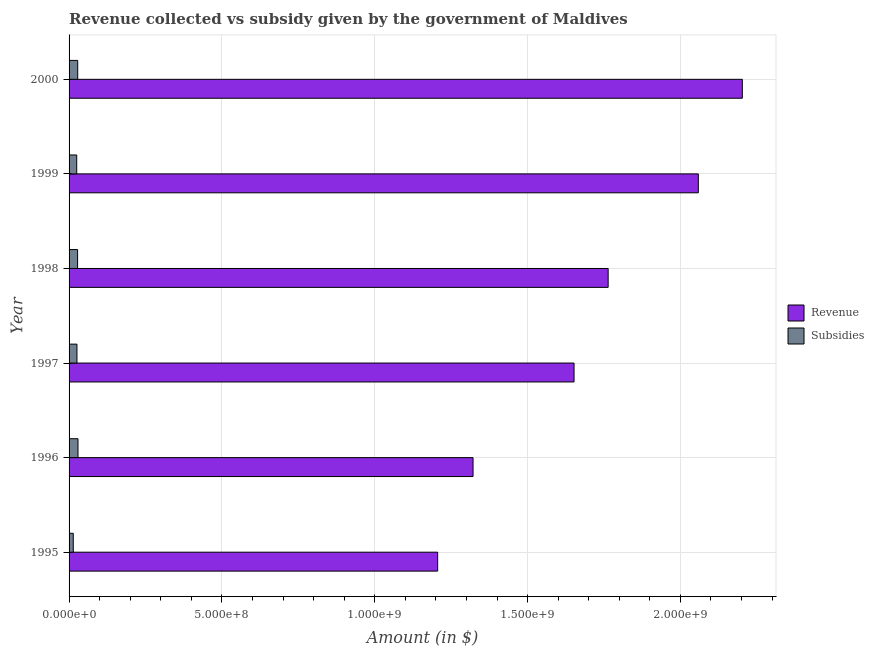How many different coloured bars are there?
Your response must be concise. 2. Are the number of bars per tick equal to the number of legend labels?
Your response must be concise. Yes. Are the number of bars on each tick of the Y-axis equal?
Keep it short and to the point. Yes. What is the label of the 1st group of bars from the top?
Your response must be concise. 2000. In how many cases, is the number of bars for a given year not equal to the number of legend labels?
Your answer should be very brief. 0. What is the amount of revenue collected in 2000?
Keep it short and to the point. 2.20e+09. Across all years, what is the maximum amount of revenue collected?
Give a very brief answer. 2.20e+09. Across all years, what is the minimum amount of subsidies given?
Offer a very short reply. 1.37e+07. What is the total amount of revenue collected in the graph?
Your response must be concise. 1.02e+1. What is the difference between the amount of revenue collected in 1996 and that in 1997?
Ensure brevity in your answer.  -3.30e+08. What is the difference between the amount of subsidies given in 1999 and the amount of revenue collected in 1996?
Offer a terse response. -1.30e+09. What is the average amount of revenue collected per year?
Your answer should be very brief. 1.70e+09. In the year 1996, what is the difference between the amount of revenue collected and amount of subsidies given?
Your response must be concise. 1.29e+09. In how many years, is the amount of revenue collected greater than 800000000 $?
Your response must be concise. 6. What is the ratio of the amount of revenue collected in 1996 to that in 1999?
Provide a succinct answer. 0.64. Is the amount of subsidies given in 1996 less than that in 2000?
Your answer should be compact. No. Is the difference between the amount of subsidies given in 1997 and 1998 greater than the difference between the amount of revenue collected in 1997 and 1998?
Ensure brevity in your answer.  Yes. What is the difference between the highest and the second highest amount of subsidies given?
Provide a succinct answer. 9.00e+05. What is the difference between the highest and the lowest amount of subsidies given?
Keep it short and to the point. 1.55e+07. What does the 1st bar from the top in 1998 represents?
Ensure brevity in your answer.  Subsidies. What does the 1st bar from the bottom in 2000 represents?
Offer a very short reply. Revenue. Where does the legend appear in the graph?
Ensure brevity in your answer.  Center right. What is the title of the graph?
Your answer should be compact. Revenue collected vs subsidy given by the government of Maldives. What is the label or title of the X-axis?
Your answer should be very brief. Amount (in $). What is the label or title of the Y-axis?
Give a very brief answer. Year. What is the Amount (in $) of Revenue in 1995?
Ensure brevity in your answer.  1.21e+09. What is the Amount (in $) of Subsidies in 1995?
Provide a succinct answer. 1.37e+07. What is the Amount (in $) in Revenue in 1996?
Your answer should be compact. 1.32e+09. What is the Amount (in $) in Subsidies in 1996?
Your answer should be compact. 2.92e+07. What is the Amount (in $) in Revenue in 1997?
Offer a terse response. 1.65e+09. What is the Amount (in $) in Subsidies in 1997?
Provide a succinct answer. 2.58e+07. What is the Amount (in $) of Revenue in 1998?
Give a very brief answer. 1.76e+09. What is the Amount (in $) of Subsidies in 1998?
Make the answer very short. 2.79e+07. What is the Amount (in $) in Revenue in 1999?
Provide a succinct answer. 2.06e+09. What is the Amount (in $) in Subsidies in 1999?
Provide a short and direct response. 2.50e+07. What is the Amount (in $) in Revenue in 2000?
Ensure brevity in your answer.  2.20e+09. What is the Amount (in $) of Subsidies in 2000?
Give a very brief answer. 2.83e+07. Across all years, what is the maximum Amount (in $) in Revenue?
Keep it short and to the point. 2.20e+09. Across all years, what is the maximum Amount (in $) of Subsidies?
Offer a terse response. 2.92e+07. Across all years, what is the minimum Amount (in $) in Revenue?
Your answer should be very brief. 1.21e+09. Across all years, what is the minimum Amount (in $) in Subsidies?
Provide a short and direct response. 1.37e+07. What is the total Amount (in $) in Revenue in the graph?
Ensure brevity in your answer.  1.02e+1. What is the total Amount (in $) of Subsidies in the graph?
Your answer should be compact. 1.50e+08. What is the difference between the Amount (in $) of Revenue in 1995 and that in 1996?
Give a very brief answer. -1.16e+08. What is the difference between the Amount (in $) in Subsidies in 1995 and that in 1996?
Ensure brevity in your answer.  -1.55e+07. What is the difference between the Amount (in $) in Revenue in 1995 and that in 1997?
Make the answer very short. -4.46e+08. What is the difference between the Amount (in $) of Subsidies in 1995 and that in 1997?
Make the answer very short. -1.21e+07. What is the difference between the Amount (in $) of Revenue in 1995 and that in 1998?
Keep it short and to the point. -5.58e+08. What is the difference between the Amount (in $) in Subsidies in 1995 and that in 1998?
Provide a short and direct response. -1.42e+07. What is the difference between the Amount (in $) in Revenue in 1995 and that in 1999?
Ensure brevity in your answer.  -8.53e+08. What is the difference between the Amount (in $) in Subsidies in 1995 and that in 1999?
Your response must be concise. -1.13e+07. What is the difference between the Amount (in $) in Revenue in 1995 and that in 2000?
Give a very brief answer. -9.97e+08. What is the difference between the Amount (in $) of Subsidies in 1995 and that in 2000?
Provide a short and direct response. -1.46e+07. What is the difference between the Amount (in $) in Revenue in 1996 and that in 1997?
Provide a succinct answer. -3.30e+08. What is the difference between the Amount (in $) of Subsidies in 1996 and that in 1997?
Ensure brevity in your answer.  3.40e+06. What is the difference between the Amount (in $) of Revenue in 1996 and that in 1998?
Ensure brevity in your answer.  -4.42e+08. What is the difference between the Amount (in $) of Subsidies in 1996 and that in 1998?
Make the answer very short. 1.30e+06. What is the difference between the Amount (in $) in Revenue in 1996 and that in 1999?
Provide a succinct answer. -7.37e+08. What is the difference between the Amount (in $) in Subsidies in 1996 and that in 1999?
Your answer should be very brief. 4.20e+06. What is the difference between the Amount (in $) in Revenue in 1996 and that in 2000?
Provide a short and direct response. -8.81e+08. What is the difference between the Amount (in $) in Revenue in 1997 and that in 1998?
Make the answer very short. -1.12e+08. What is the difference between the Amount (in $) of Subsidies in 1997 and that in 1998?
Your response must be concise. -2.10e+06. What is the difference between the Amount (in $) in Revenue in 1997 and that in 1999?
Provide a short and direct response. -4.07e+08. What is the difference between the Amount (in $) in Revenue in 1997 and that in 2000?
Your answer should be compact. -5.51e+08. What is the difference between the Amount (in $) in Subsidies in 1997 and that in 2000?
Provide a succinct answer. -2.50e+06. What is the difference between the Amount (in $) of Revenue in 1998 and that in 1999?
Give a very brief answer. -2.95e+08. What is the difference between the Amount (in $) of Subsidies in 1998 and that in 1999?
Your answer should be compact. 2.90e+06. What is the difference between the Amount (in $) in Revenue in 1998 and that in 2000?
Make the answer very short. -4.39e+08. What is the difference between the Amount (in $) in Subsidies in 1998 and that in 2000?
Your answer should be very brief. -4.00e+05. What is the difference between the Amount (in $) in Revenue in 1999 and that in 2000?
Make the answer very short. -1.44e+08. What is the difference between the Amount (in $) of Subsidies in 1999 and that in 2000?
Provide a succinct answer. -3.30e+06. What is the difference between the Amount (in $) of Revenue in 1995 and the Amount (in $) of Subsidies in 1996?
Keep it short and to the point. 1.18e+09. What is the difference between the Amount (in $) of Revenue in 1995 and the Amount (in $) of Subsidies in 1997?
Give a very brief answer. 1.18e+09. What is the difference between the Amount (in $) of Revenue in 1995 and the Amount (in $) of Subsidies in 1998?
Your response must be concise. 1.18e+09. What is the difference between the Amount (in $) of Revenue in 1995 and the Amount (in $) of Subsidies in 1999?
Offer a terse response. 1.18e+09. What is the difference between the Amount (in $) in Revenue in 1995 and the Amount (in $) in Subsidies in 2000?
Give a very brief answer. 1.18e+09. What is the difference between the Amount (in $) of Revenue in 1996 and the Amount (in $) of Subsidies in 1997?
Provide a succinct answer. 1.30e+09. What is the difference between the Amount (in $) of Revenue in 1996 and the Amount (in $) of Subsidies in 1998?
Keep it short and to the point. 1.29e+09. What is the difference between the Amount (in $) of Revenue in 1996 and the Amount (in $) of Subsidies in 1999?
Make the answer very short. 1.30e+09. What is the difference between the Amount (in $) of Revenue in 1996 and the Amount (in $) of Subsidies in 2000?
Keep it short and to the point. 1.29e+09. What is the difference between the Amount (in $) in Revenue in 1997 and the Amount (in $) in Subsidies in 1998?
Offer a very short reply. 1.62e+09. What is the difference between the Amount (in $) in Revenue in 1997 and the Amount (in $) in Subsidies in 1999?
Your answer should be very brief. 1.63e+09. What is the difference between the Amount (in $) of Revenue in 1997 and the Amount (in $) of Subsidies in 2000?
Ensure brevity in your answer.  1.62e+09. What is the difference between the Amount (in $) of Revenue in 1998 and the Amount (in $) of Subsidies in 1999?
Make the answer very short. 1.74e+09. What is the difference between the Amount (in $) of Revenue in 1998 and the Amount (in $) of Subsidies in 2000?
Offer a very short reply. 1.74e+09. What is the difference between the Amount (in $) of Revenue in 1999 and the Amount (in $) of Subsidies in 2000?
Keep it short and to the point. 2.03e+09. What is the average Amount (in $) in Revenue per year?
Ensure brevity in your answer.  1.70e+09. What is the average Amount (in $) in Subsidies per year?
Give a very brief answer. 2.50e+07. In the year 1995, what is the difference between the Amount (in $) in Revenue and Amount (in $) in Subsidies?
Your answer should be compact. 1.19e+09. In the year 1996, what is the difference between the Amount (in $) in Revenue and Amount (in $) in Subsidies?
Provide a succinct answer. 1.29e+09. In the year 1997, what is the difference between the Amount (in $) of Revenue and Amount (in $) of Subsidies?
Keep it short and to the point. 1.63e+09. In the year 1998, what is the difference between the Amount (in $) of Revenue and Amount (in $) of Subsidies?
Provide a short and direct response. 1.74e+09. In the year 1999, what is the difference between the Amount (in $) in Revenue and Amount (in $) in Subsidies?
Provide a short and direct response. 2.03e+09. In the year 2000, what is the difference between the Amount (in $) in Revenue and Amount (in $) in Subsidies?
Keep it short and to the point. 2.17e+09. What is the ratio of the Amount (in $) of Revenue in 1995 to that in 1996?
Provide a short and direct response. 0.91. What is the ratio of the Amount (in $) of Subsidies in 1995 to that in 1996?
Provide a short and direct response. 0.47. What is the ratio of the Amount (in $) in Revenue in 1995 to that in 1997?
Keep it short and to the point. 0.73. What is the ratio of the Amount (in $) of Subsidies in 1995 to that in 1997?
Keep it short and to the point. 0.53. What is the ratio of the Amount (in $) of Revenue in 1995 to that in 1998?
Provide a short and direct response. 0.68. What is the ratio of the Amount (in $) in Subsidies in 1995 to that in 1998?
Your response must be concise. 0.49. What is the ratio of the Amount (in $) in Revenue in 1995 to that in 1999?
Make the answer very short. 0.59. What is the ratio of the Amount (in $) in Subsidies in 1995 to that in 1999?
Give a very brief answer. 0.55. What is the ratio of the Amount (in $) of Revenue in 1995 to that in 2000?
Give a very brief answer. 0.55. What is the ratio of the Amount (in $) in Subsidies in 1995 to that in 2000?
Make the answer very short. 0.48. What is the ratio of the Amount (in $) in Revenue in 1996 to that in 1997?
Your answer should be compact. 0.8. What is the ratio of the Amount (in $) in Subsidies in 1996 to that in 1997?
Make the answer very short. 1.13. What is the ratio of the Amount (in $) of Revenue in 1996 to that in 1998?
Your response must be concise. 0.75. What is the ratio of the Amount (in $) in Subsidies in 1996 to that in 1998?
Ensure brevity in your answer.  1.05. What is the ratio of the Amount (in $) of Revenue in 1996 to that in 1999?
Provide a short and direct response. 0.64. What is the ratio of the Amount (in $) in Subsidies in 1996 to that in 1999?
Give a very brief answer. 1.17. What is the ratio of the Amount (in $) in Revenue in 1996 to that in 2000?
Keep it short and to the point. 0.6. What is the ratio of the Amount (in $) in Subsidies in 1996 to that in 2000?
Offer a very short reply. 1.03. What is the ratio of the Amount (in $) of Revenue in 1997 to that in 1998?
Make the answer very short. 0.94. What is the ratio of the Amount (in $) of Subsidies in 1997 to that in 1998?
Give a very brief answer. 0.92. What is the ratio of the Amount (in $) of Revenue in 1997 to that in 1999?
Your answer should be very brief. 0.8. What is the ratio of the Amount (in $) in Subsidies in 1997 to that in 1999?
Make the answer very short. 1.03. What is the ratio of the Amount (in $) in Revenue in 1997 to that in 2000?
Keep it short and to the point. 0.75. What is the ratio of the Amount (in $) of Subsidies in 1997 to that in 2000?
Keep it short and to the point. 0.91. What is the ratio of the Amount (in $) of Revenue in 1998 to that in 1999?
Keep it short and to the point. 0.86. What is the ratio of the Amount (in $) in Subsidies in 1998 to that in 1999?
Make the answer very short. 1.12. What is the ratio of the Amount (in $) in Revenue in 1998 to that in 2000?
Provide a succinct answer. 0.8. What is the ratio of the Amount (in $) of Subsidies in 1998 to that in 2000?
Offer a terse response. 0.99. What is the ratio of the Amount (in $) in Revenue in 1999 to that in 2000?
Offer a terse response. 0.93. What is the ratio of the Amount (in $) of Subsidies in 1999 to that in 2000?
Offer a very short reply. 0.88. What is the difference between the highest and the second highest Amount (in $) in Revenue?
Give a very brief answer. 1.44e+08. What is the difference between the highest and the lowest Amount (in $) in Revenue?
Ensure brevity in your answer.  9.97e+08. What is the difference between the highest and the lowest Amount (in $) of Subsidies?
Provide a succinct answer. 1.55e+07. 